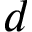<formula> <loc_0><loc_0><loc_500><loc_500>d</formula> 